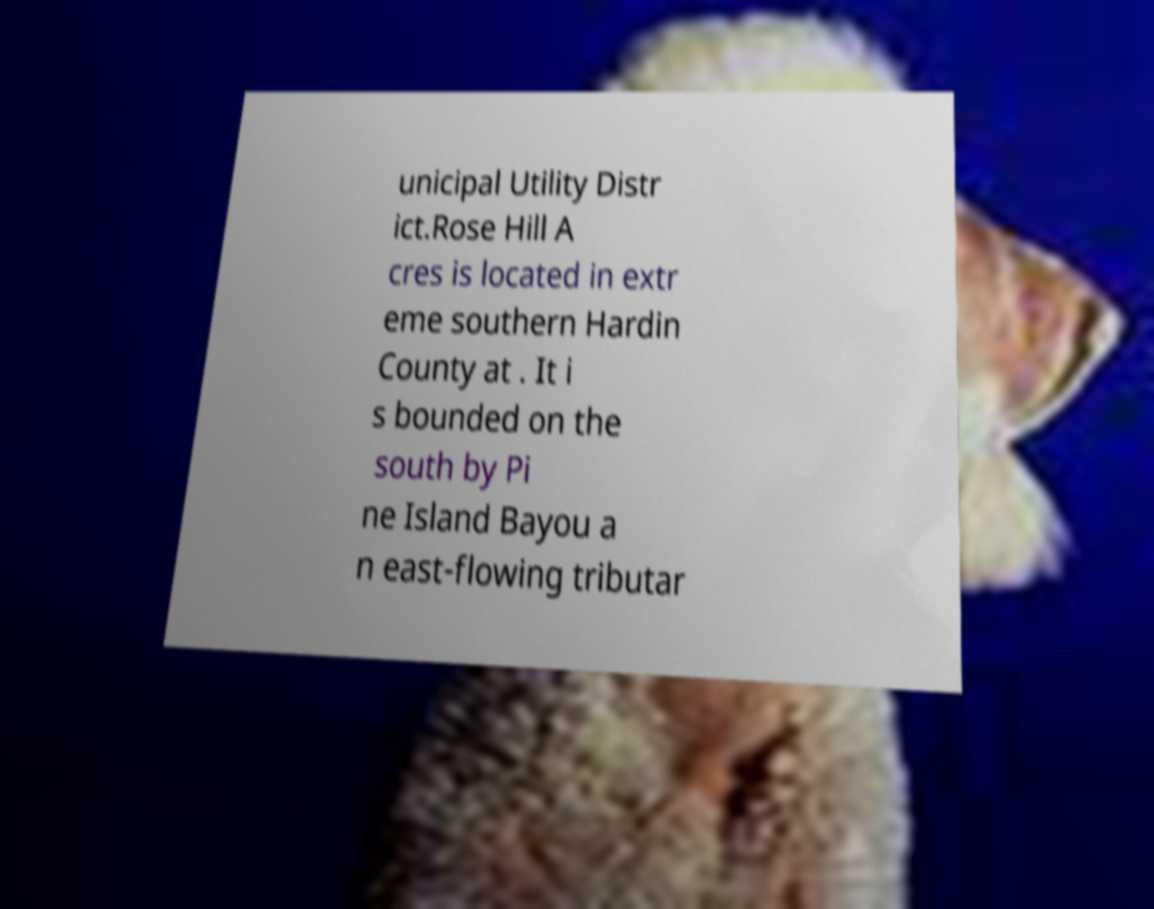Can you read and provide the text displayed in the image?This photo seems to have some interesting text. Can you extract and type it out for me? unicipal Utility Distr ict.Rose Hill A cres is located in extr eme southern Hardin County at . It i s bounded on the south by Pi ne Island Bayou a n east-flowing tributar 